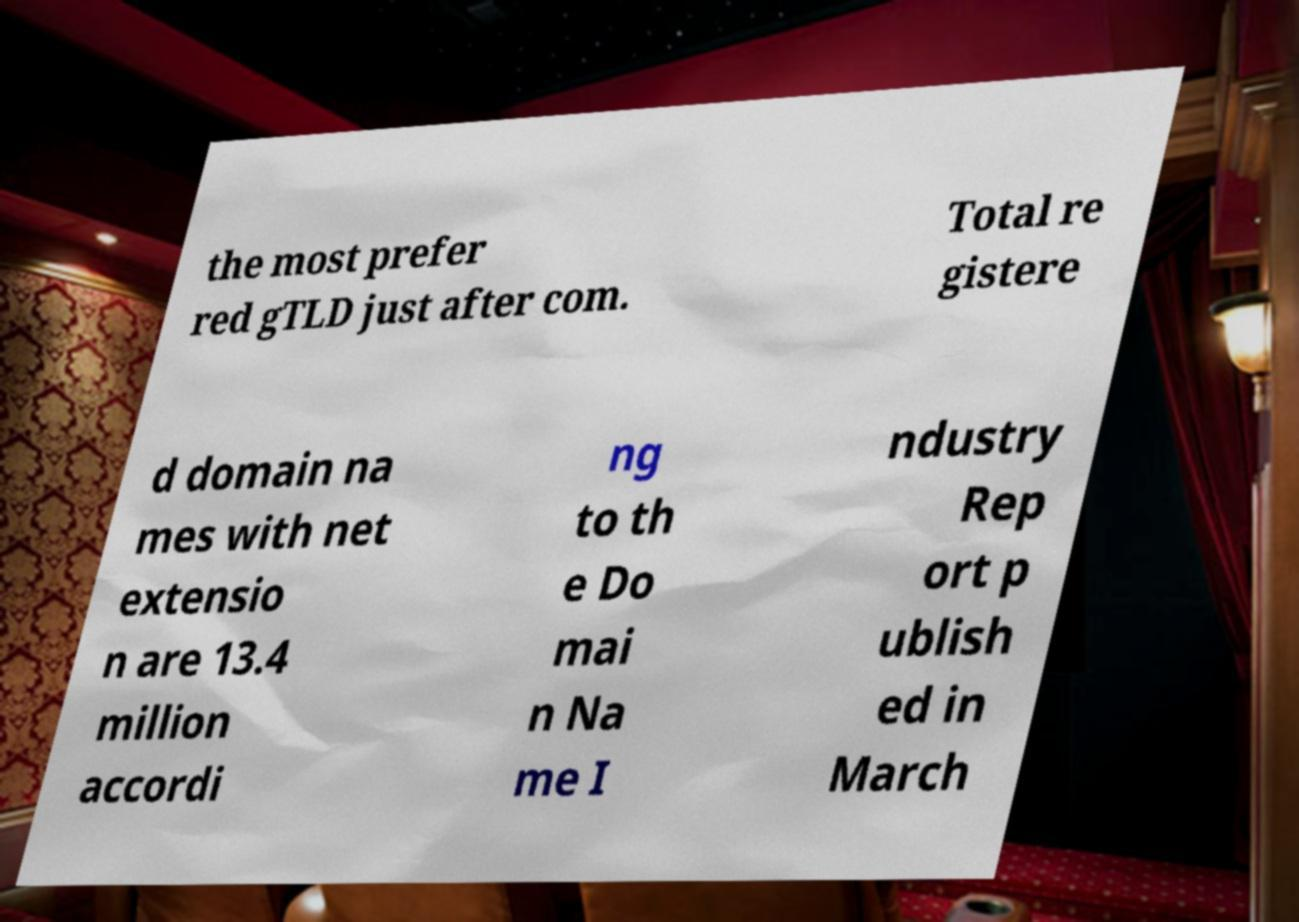What messages or text are displayed in this image? I need them in a readable, typed format. the most prefer red gTLD just after com. Total re gistere d domain na mes with net extensio n are 13.4 million accordi ng to th e Do mai n Na me I ndustry Rep ort p ublish ed in March 